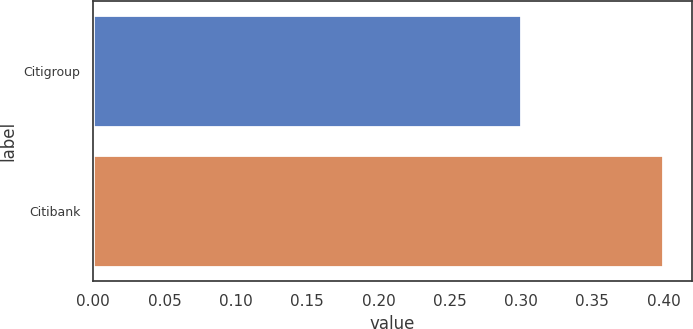Convert chart to OTSL. <chart><loc_0><loc_0><loc_500><loc_500><bar_chart><fcel>Citigroup<fcel>Citibank<nl><fcel>0.3<fcel>0.4<nl></chart> 